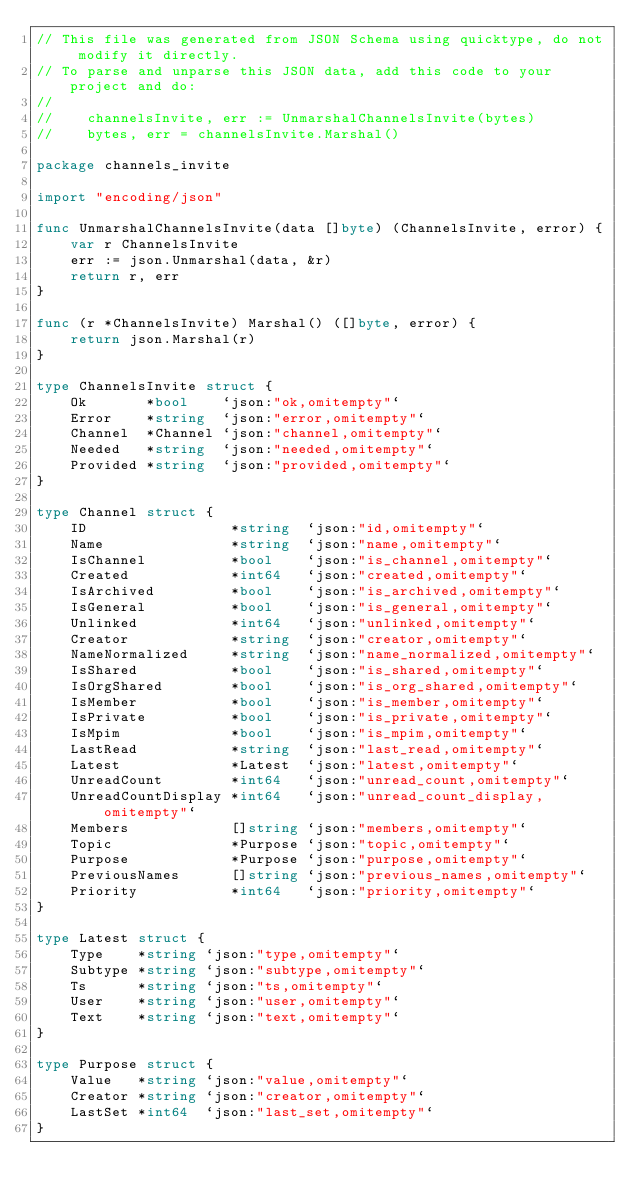Convert code to text. <code><loc_0><loc_0><loc_500><loc_500><_Go_>// This file was generated from JSON Schema using quicktype, do not modify it directly.
// To parse and unparse this JSON data, add this code to your project and do:
//
//    channelsInvite, err := UnmarshalChannelsInvite(bytes)
//    bytes, err = channelsInvite.Marshal()

package channels_invite

import "encoding/json"

func UnmarshalChannelsInvite(data []byte) (ChannelsInvite, error) {
	var r ChannelsInvite
	err := json.Unmarshal(data, &r)
	return r, err
}

func (r *ChannelsInvite) Marshal() ([]byte, error) {
	return json.Marshal(r)
}

type ChannelsInvite struct {
	Ok       *bool    `json:"ok,omitempty"`      
	Error    *string  `json:"error,omitempty"`   
	Channel  *Channel `json:"channel,omitempty"` 
	Needed   *string  `json:"needed,omitempty"`  
	Provided *string  `json:"provided,omitempty"`
}

type Channel struct {
	ID                 *string  `json:"id,omitempty"`                  
	Name               *string  `json:"name,omitempty"`                
	IsChannel          *bool    `json:"is_channel,omitempty"`          
	Created            *int64   `json:"created,omitempty"`             
	IsArchived         *bool    `json:"is_archived,omitempty"`         
	IsGeneral          *bool    `json:"is_general,omitempty"`          
	Unlinked           *int64   `json:"unlinked,omitempty"`            
	Creator            *string  `json:"creator,omitempty"`             
	NameNormalized     *string  `json:"name_normalized,omitempty"`     
	IsShared           *bool    `json:"is_shared,omitempty"`           
	IsOrgShared        *bool    `json:"is_org_shared,omitempty"`       
	IsMember           *bool    `json:"is_member,omitempty"`           
	IsPrivate          *bool    `json:"is_private,omitempty"`          
	IsMpim             *bool    `json:"is_mpim,omitempty"`             
	LastRead           *string  `json:"last_read,omitempty"`           
	Latest             *Latest  `json:"latest,omitempty"`              
	UnreadCount        *int64   `json:"unread_count,omitempty"`        
	UnreadCountDisplay *int64   `json:"unread_count_display,omitempty"`
	Members            []string `json:"members,omitempty"`             
	Topic              *Purpose `json:"topic,omitempty"`               
	Purpose            *Purpose `json:"purpose,omitempty"`             
	PreviousNames      []string `json:"previous_names,omitempty"`      
	Priority           *int64   `json:"priority,omitempty"`            
}

type Latest struct {
	Type    *string `json:"type,omitempty"`   
	Subtype *string `json:"subtype,omitempty"`
	Ts      *string `json:"ts,omitempty"`     
	User    *string `json:"user,omitempty"`   
	Text    *string `json:"text,omitempty"`   
}

type Purpose struct {
	Value   *string `json:"value,omitempty"`   
	Creator *string `json:"creator,omitempty"` 
	LastSet *int64  `json:"last_set,omitempty"`
}
</code> 